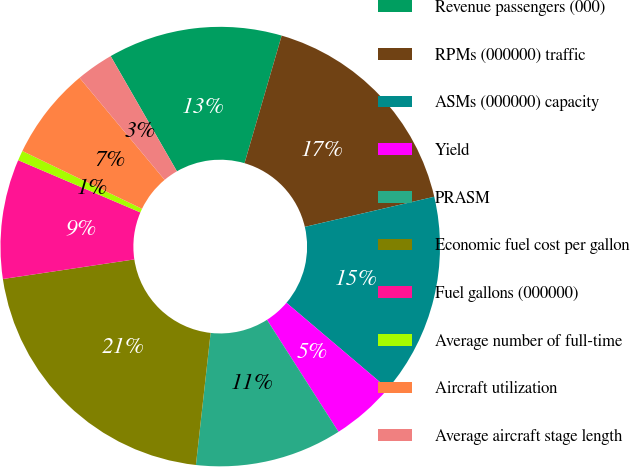Convert chart. <chart><loc_0><loc_0><loc_500><loc_500><pie_chart><fcel>Revenue passengers (000)<fcel>RPMs (000000) traffic<fcel>ASMs (000000) capacity<fcel>Yield<fcel>PRASM<fcel>Economic fuel cost per gallon<fcel>Fuel gallons (000000)<fcel>Average number of full-time<fcel>Aircraft utilization<fcel>Average aircraft stage length<nl><fcel>12.82%<fcel>16.85%<fcel>14.84%<fcel>4.76%<fcel>10.81%<fcel>20.88%<fcel>8.79%<fcel>0.73%<fcel>6.78%<fcel>2.75%<nl></chart> 